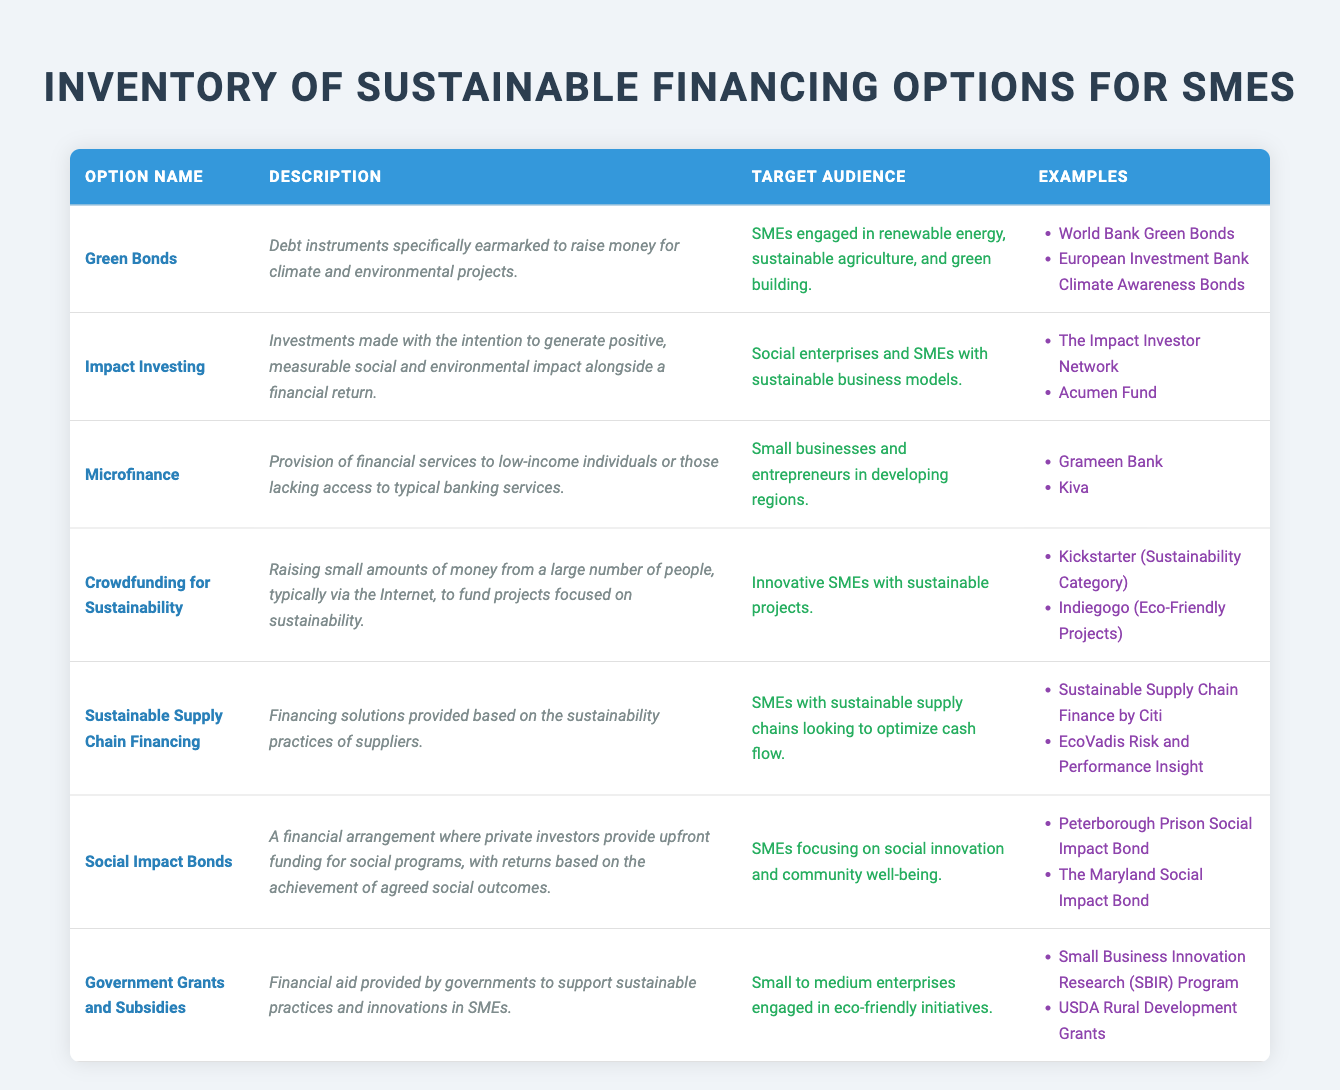What is the target audience for Green Bonds? The "Target Audience" column for Green Bonds lists "SMEs engaged in renewable energy, sustainable agriculture, and green building." This information is found directly in the corresponding row of the table.
Answer: SMEs engaged in renewable energy, sustainable agriculture, and green building How many financing options specifically target SMEs focusing on social innovation? To answer this, we can look at the "Target Audience" descriptions for all options. "Social Impact Bonds" is the only one that specifies targeting SMEs focusing on social innovation, so the count is one.
Answer: 1 Is Impact Investing aimed at SMEs that have sustainable business models? The description in the "Target Audience" column for Impact Investing states "Social enterprises and SMEs with sustainable business models." This confirms that the statement is true.
Answer: Yes Which financing option describes investments aimed at generating measurable social and environmental impact? The description under "Impact Investing" states that it involves "Investments made with the intention to generate positive, measurable social and environmental impact alongside a financial return." Thus, this option clearly matches the question.
Answer: Impact Investing How many financing options listed offer examples of specific programs or initiatives? To answer this, we need to see how many options have examples listed in the "Examples" column. All options have at least two examples each, totaling seven options.
Answer: 7 Which financing options target small to medium enterprises engaged in eco-friendly initiatives? The "Target Audience" column for Government Grants and Subsidies specifies "Small to medium enterprises engaged in eco-friendly initiatives." This is the sole financing option that directly matches this criterion.
Answer: Government Grants and Subsidies What is the common characteristic of SMEs targeted by Sustainable Supply Chain Financing? The "Target Audience" for Sustainable Supply Chain Financing states "SMEs with sustainable supply chains looking to optimize cash flow." This shows that the common characteristic is the sustainability of their supply chains.
Answer: Sustainability of their supply chains How does the description of Microfinance differ from that of crowdfunding? Microfinance focuses on providing financial services to low-income individuals or those lacking typical banking access, whereas Crowdfunding for Sustainability aims at raising small amounts from many people to fund sustainability projects. The descriptions reveal distinct purposes for each financing option.
Answer: They focus on different purposes; Microfinance targets low-income individuals, while crowdfunding targets sustainability projects 